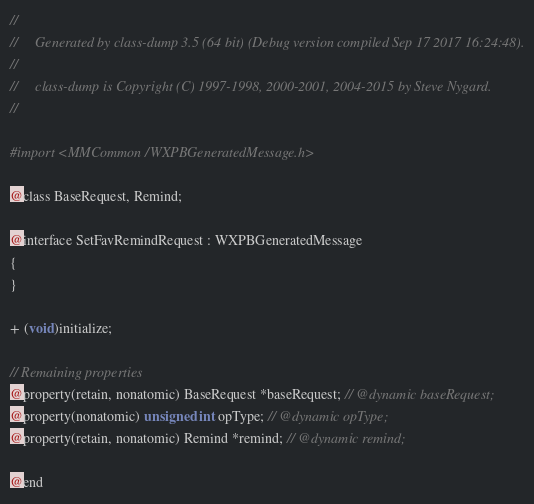Convert code to text. <code><loc_0><loc_0><loc_500><loc_500><_C_>//
//     Generated by class-dump 3.5 (64 bit) (Debug version compiled Sep 17 2017 16:24:48).
//
//     class-dump is Copyright (C) 1997-1998, 2000-2001, 2004-2015 by Steve Nygard.
//

#import <MMCommon/WXPBGeneratedMessage.h>

@class BaseRequest, Remind;

@interface SetFavRemindRequest : WXPBGeneratedMessage
{
}

+ (void)initialize;

// Remaining properties
@property(retain, nonatomic) BaseRequest *baseRequest; // @dynamic baseRequest;
@property(nonatomic) unsigned int opType; // @dynamic opType;
@property(retain, nonatomic) Remind *remind; // @dynamic remind;

@end

</code> 